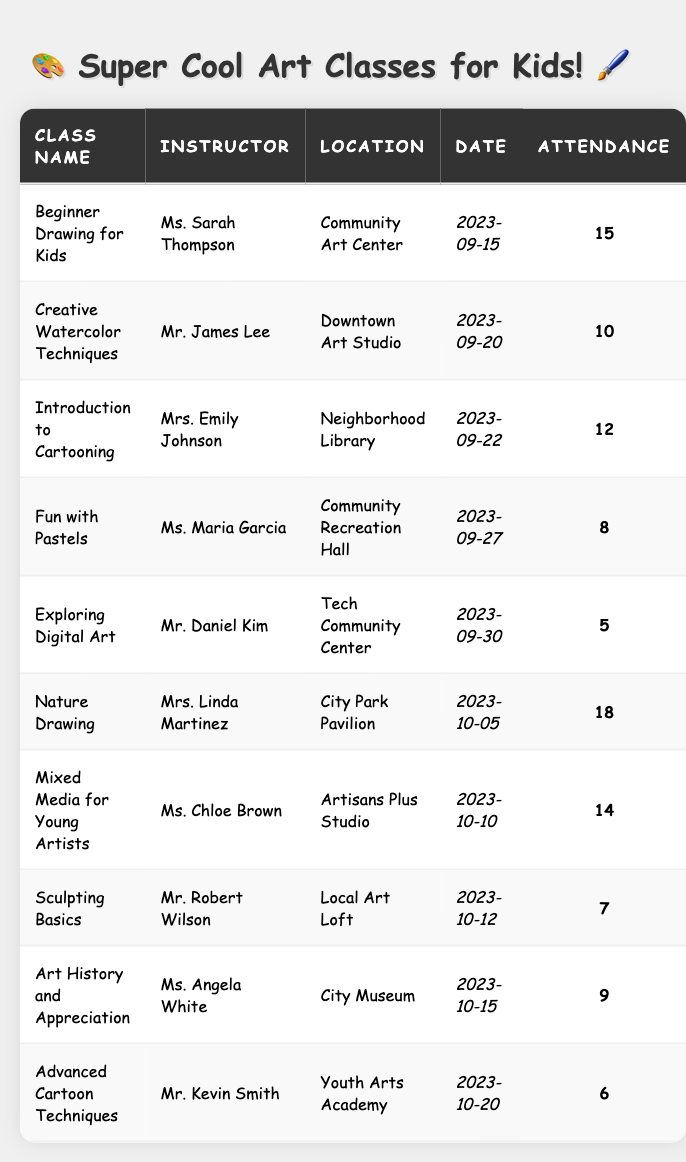What is the name of the instructor for the "Nature Drawing" class? The "Nature Drawing" class can be found in the table. By looking at the row for that class, Ms. Linda Martinez is listed as the instructor.
Answer: Ms. Linda Martinez How many kids attended the "Introduction to Cartooning" class? From the row corresponding to "Introduction to Cartooning", we can see that the attendance is listed as 12 kids.
Answer: 12 kids Which class had the highest attendance? By examining the attendance numbers in all the rows, "Nature Drawing" has the highest attendance with 18 kids.
Answer: "Nature Drawing" How many classes had an attendance of 10 or more? We count the classes with attendance of 10 or more, which are: "Beginner Drawing for Kids" (15), "Creative Watercolor Techniques" (10), "Introduction to Cartooning" (12), "Nature Drawing" (18), "Mixed Media for Young Artists" (14). That totals 5 classes.
Answer: 5 classes What is the attendance difference between the "Exploring Digital Art" and "Fun with Pastels" classes? The attendance for "Exploring Digital Art" is 5, and for "Fun with Pastels", it is 8. The difference is calculated as 8 - 5 = 3.
Answer: 3 Is there a class taught by Mr. Kevin Smith? By scanning through the instructor names in the table, we can confirm that there is a class called "Advanced Cartoon Techniques" taught by Mr. Kevin Smith.
Answer: Yes Which location had the lowest attendance, and how many kids attended? Looking at the locations and their attendance, "Exploring Digital Art" at the Tech Community Center had the lowest attendance of 5 kids.
Answer: Tech Community Center, 5 kids Calculate the average attendance of all classes in the table. The total attendance is 15 + 10 + 12 + 8 + 5 + 18 + 14 + 7 + 9 + 6 = 88, and there are 10 classes. The average is 88/10 = 8.8.
Answer: 8.8 How many kids attended classes at the "Community Art Center"? Checking the table, there is one class called "Beginner Drawing for Kids" at the "Community Art Center" with an attendance of 15 kids.
Answer: 15 kids What is the total attendance for the classes held in October? The classes in October are "Nature Drawing" (attendance 18), "Mixed Media for Young Artists" (14), "Sculpting Basics" (7), "Art History and Appreciation" (9), "Advanced Cartoon Techniques" (6). Summing these, we have 18 + 14 + 7 + 9 + 6 = 54.
Answer: 54 